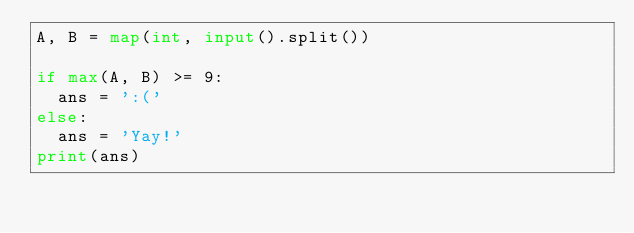<code> <loc_0><loc_0><loc_500><loc_500><_Python_>A, B = map(int, input().split())

if max(A, B) >= 9:
  ans = ':('
else:
  ans = 'Yay!'
print(ans)</code> 